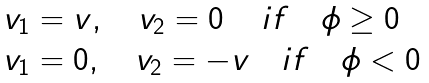<formula> <loc_0><loc_0><loc_500><loc_500>\begin{array} { l } v _ { 1 } = v , \quad v _ { 2 } = 0 \quad \, i f \quad \phi \geq 0 \\ v _ { 1 } = 0 , \quad v _ { 2 } = - v \quad i f \quad \phi < 0 \end{array}</formula> 